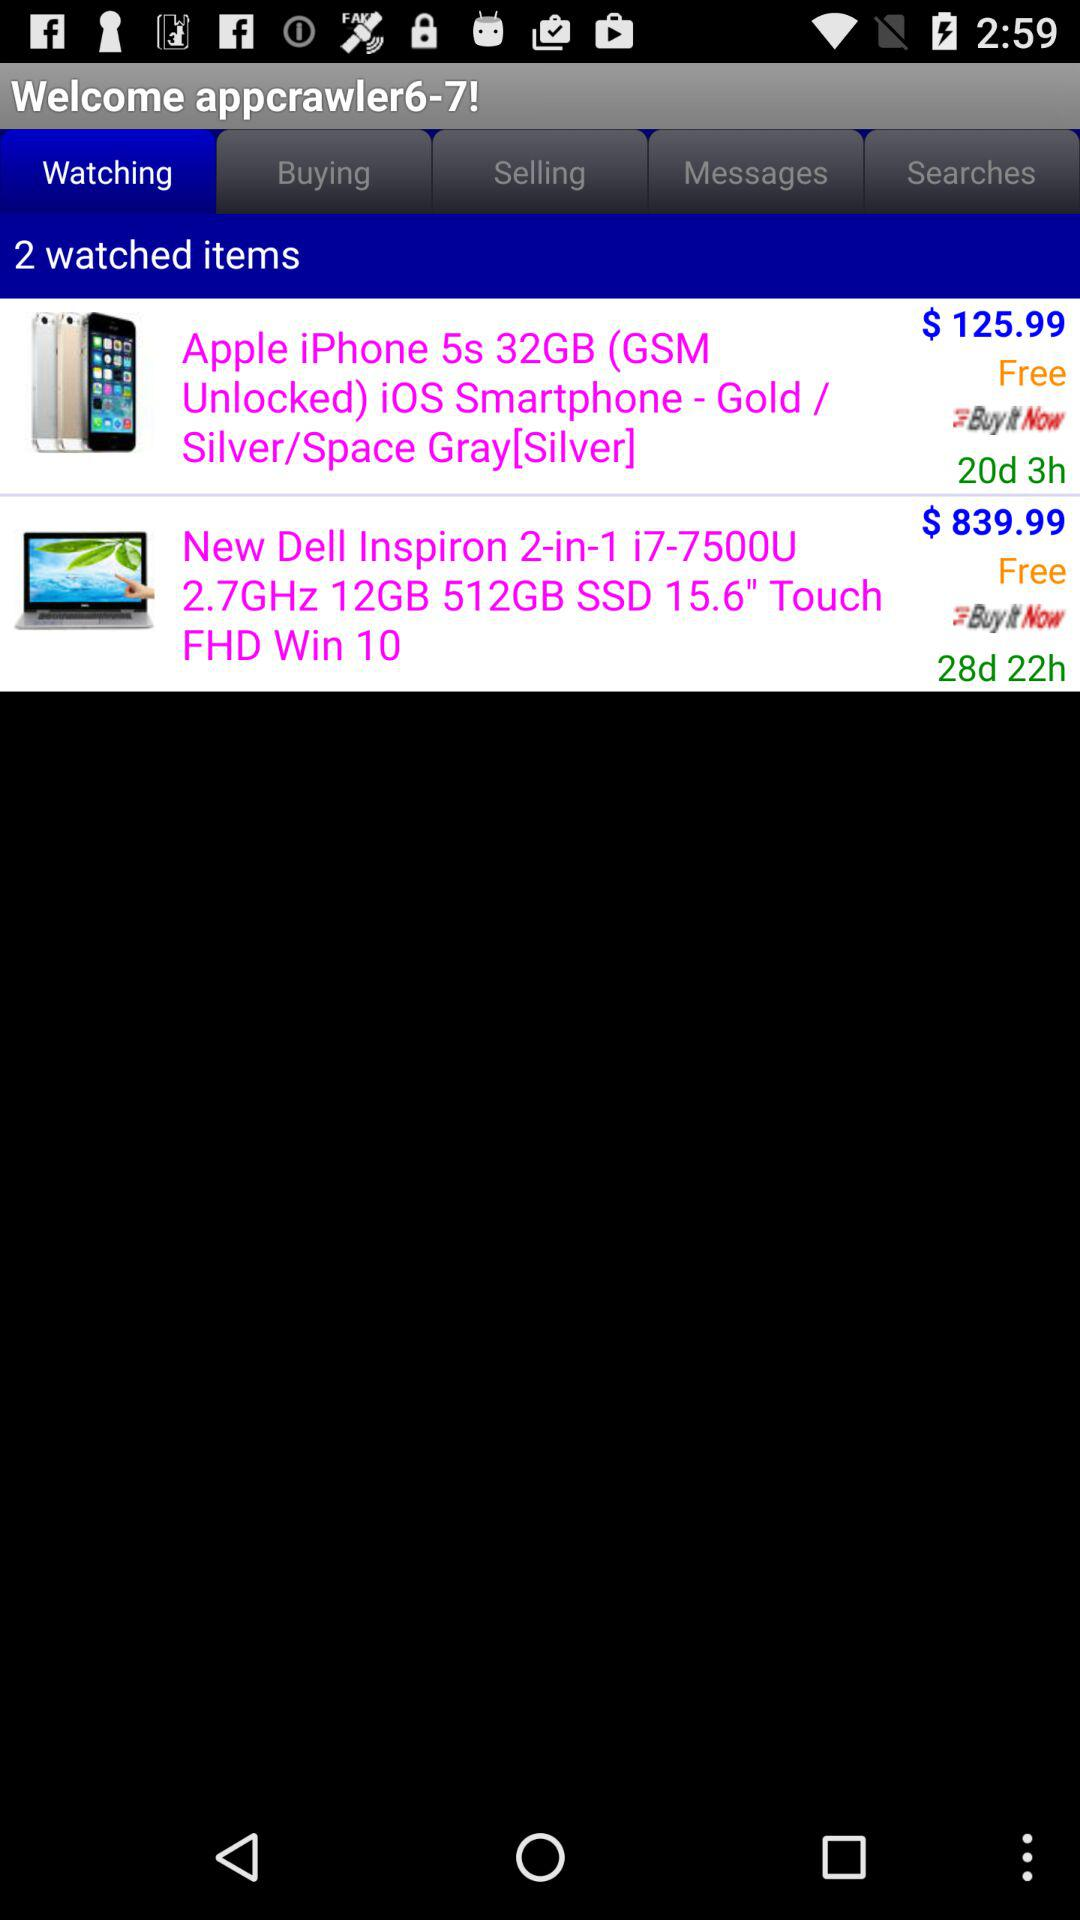What item is priced at $839.99? The item is "New Dell Inspiron 2-in-1". 